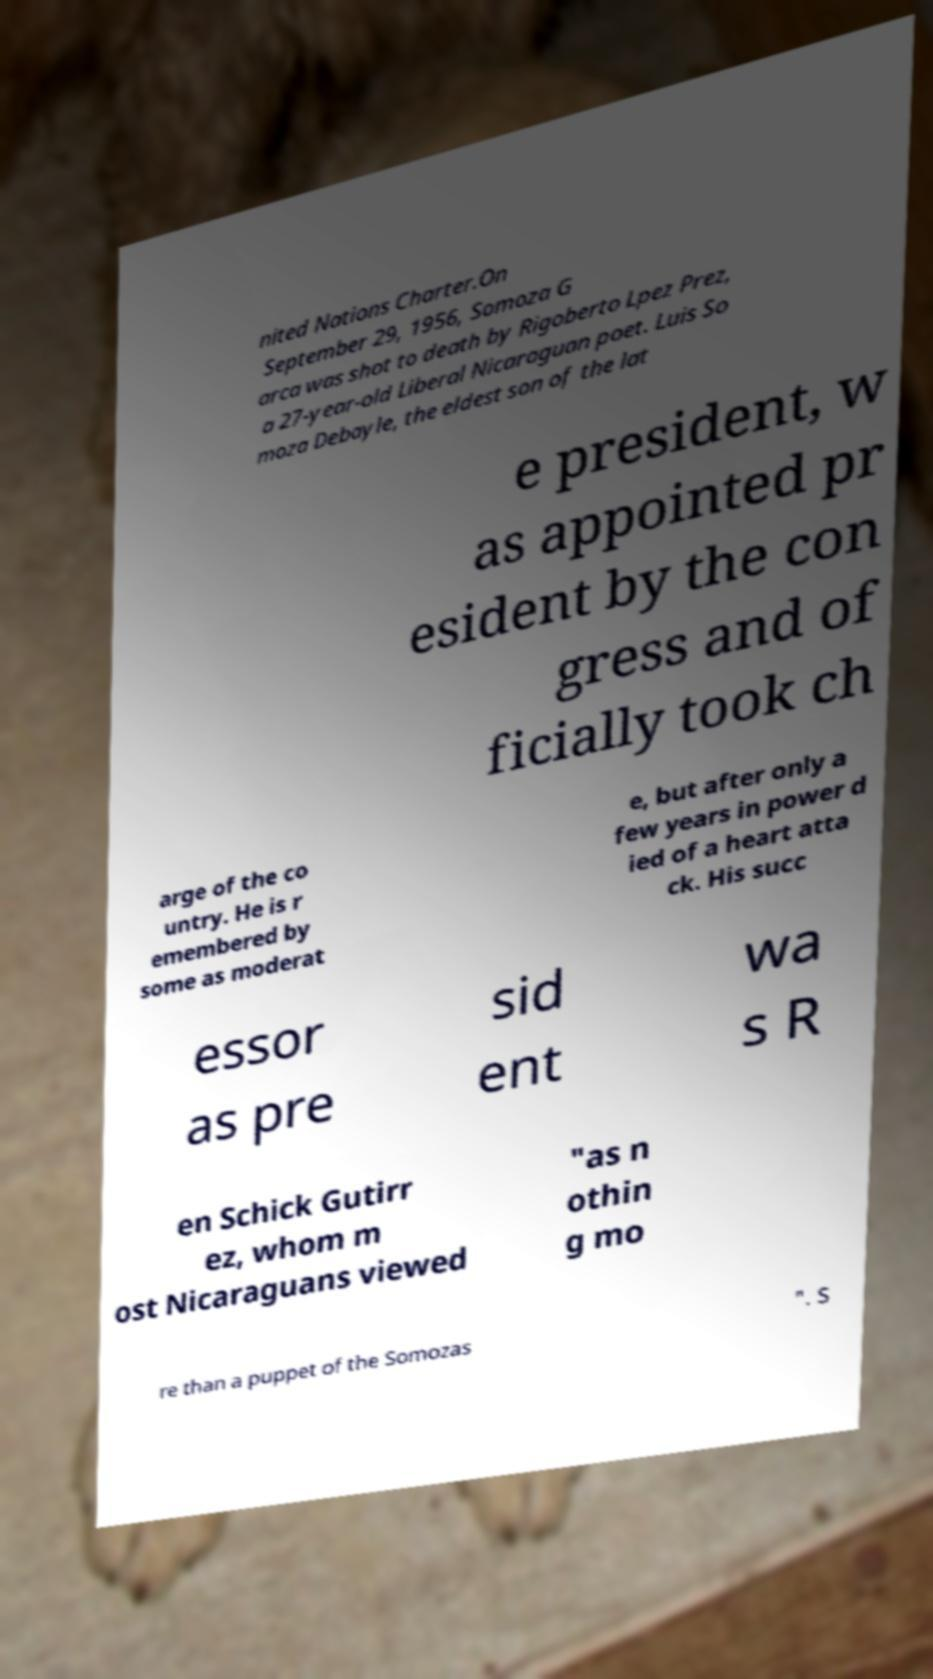Can you accurately transcribe the text from the provided image for me? nited Nations Charter.On September 29, 1956, Somoza G arca was shot to death by Rigoberto Lpez Prez, a 27-year-old Liberal Nicaraguan poet. Luis So moza Debayle, the eldest son of the lat e president, w as appointed pr esident by the con gress and of ficially took ch arge of the co untry. He is r emembered by some as moderat e, but after only a few years in power d ied of a heart atta ck. His succ essor as pre sid ent wa s R en Schick Gutirr ez, whom m ost Nicaraguans viewed "as n othin g mo re than a puppet of the Somozas ". S 